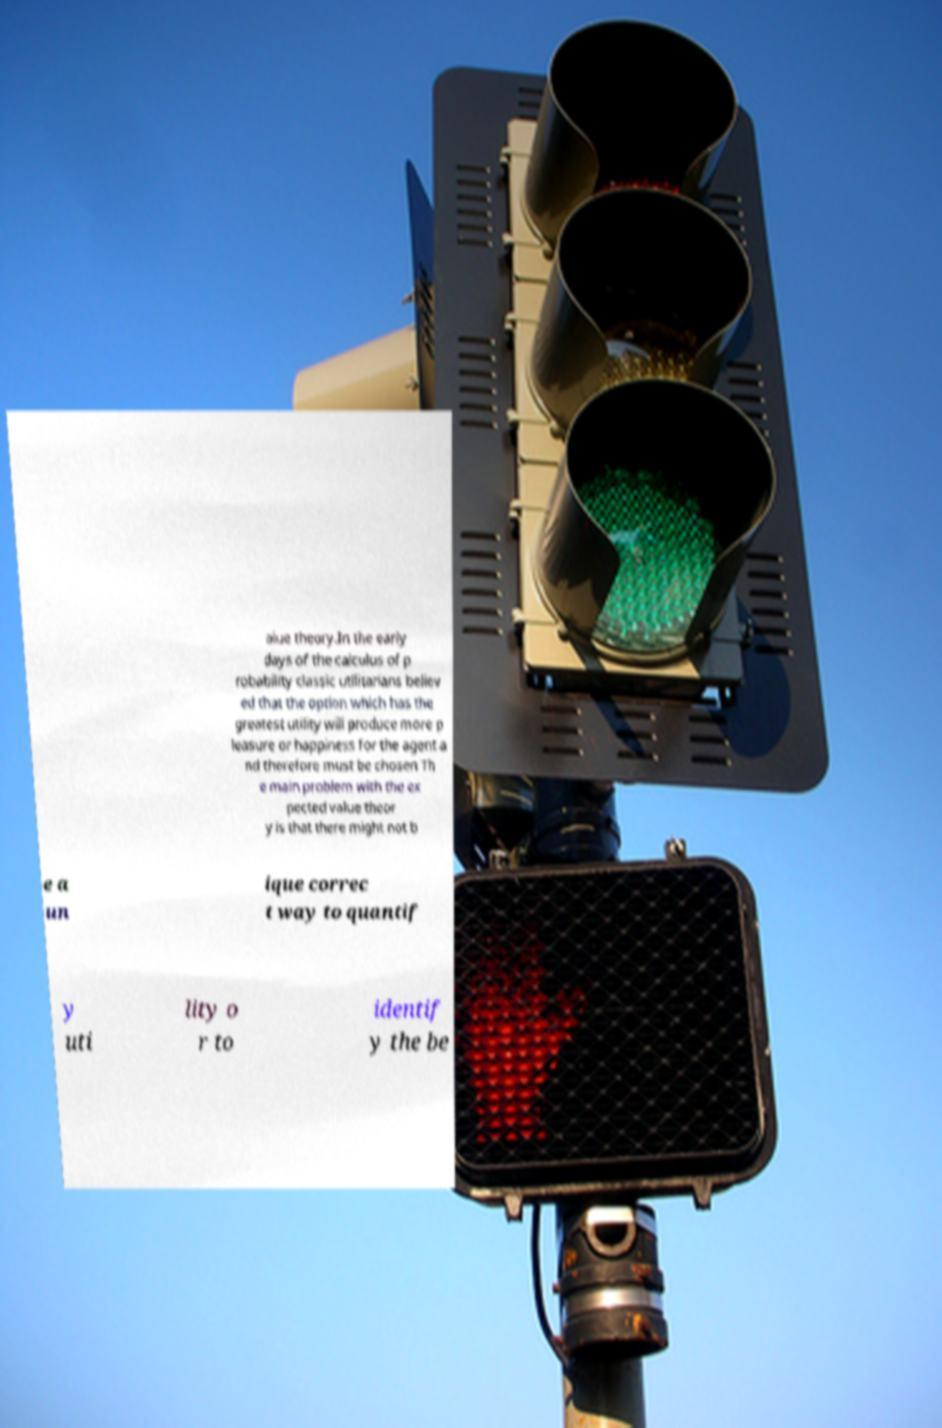Please identify and transcribe the text found in this image. alue theory.In the early days of the calculus of p robability classic utilitarians believ ed that the option which has the greatest utility will produce more p leasure or happiness for the agent a nd therefore must be chosen Th e main problem with the ex pected value theor y is that there might not b e a un ique correc t way to quantif y uti lity o r to identif y the be 